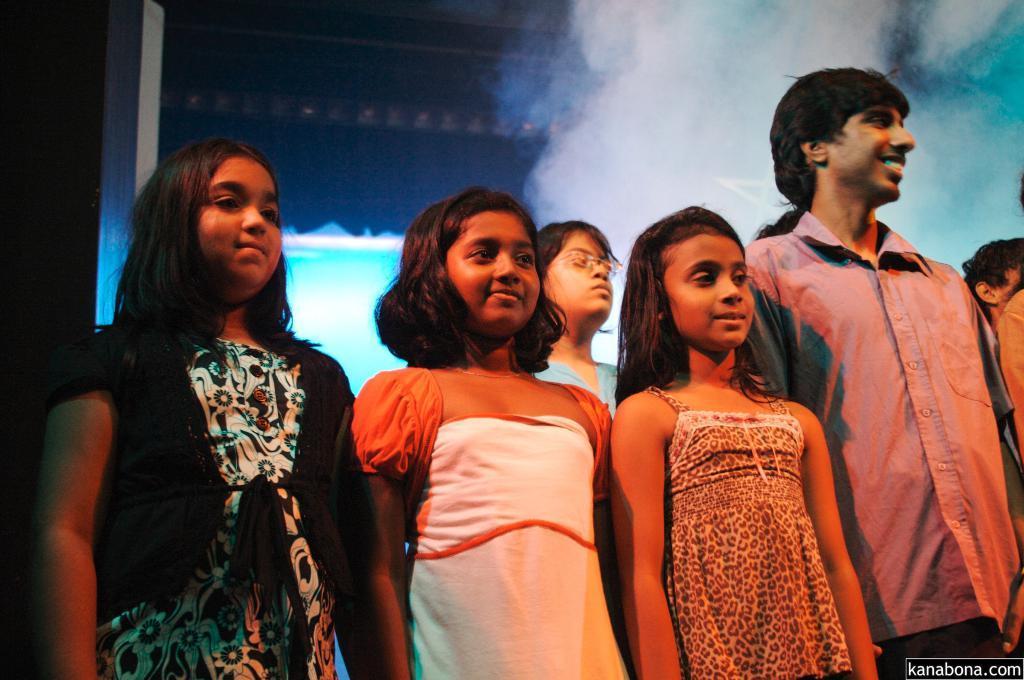How would you summarize this image in a sentence or two? In this image in the center there are a group of children who are standing, and in the background there is a fog and a wall. 